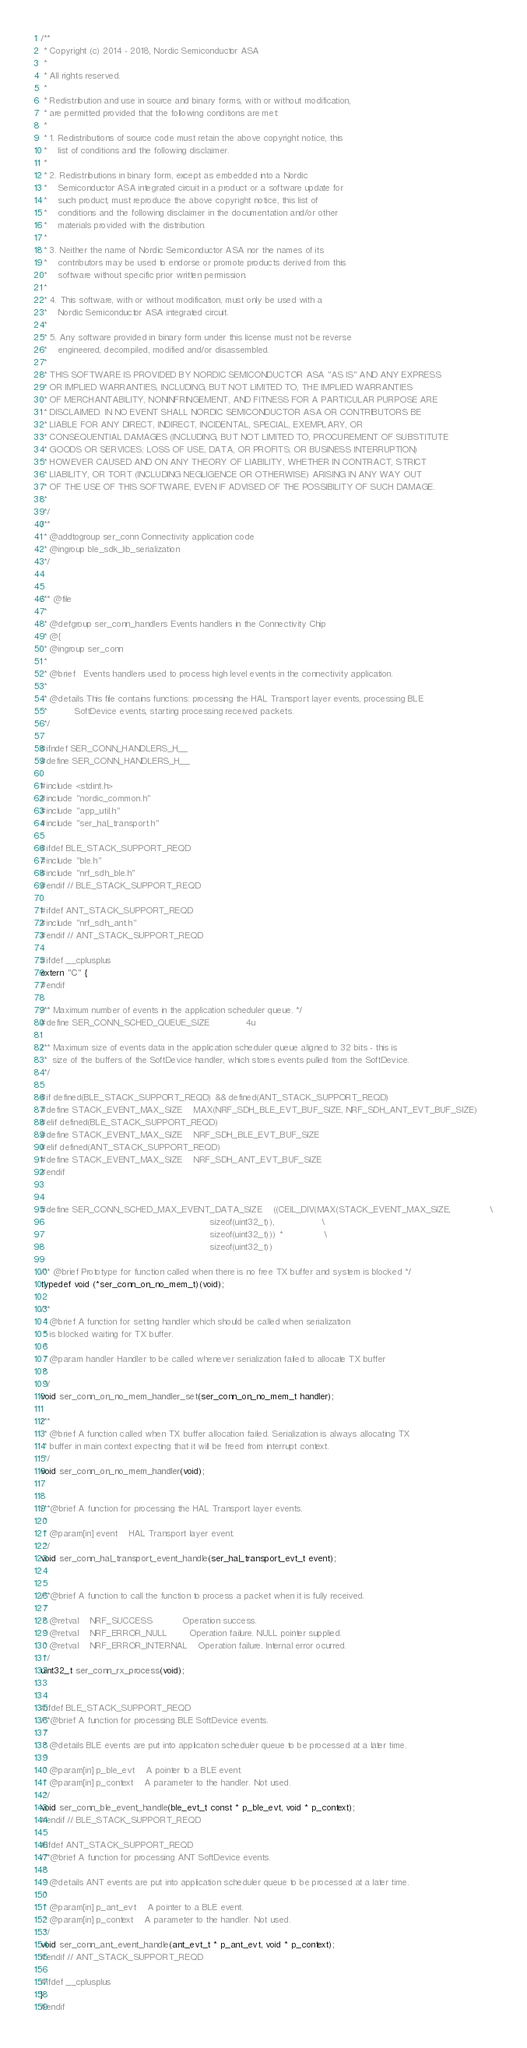<code> <loc_0><loc_0><loc_500><loc_500><_C_>/**
 * Copyright (c) 2014 - 2018, Nordic Semiconductor ASA
 * 
 * All rights reserved.
 * 
 * Redistribution and use in source and binary forms, with or without modification,
 * are permitted provided that the following conditions are met:
 * 
 * 1. Redistributions of source code must retain the above copyright notice, this
 *    list of conditions and the following disclaimer.
 * 
 * 2. Redistributions in binary form, except as embedded into a Nordic
 *    Semiconductor ASA integrated circuit in a product or a software update for
 *    such product, must reproduce the above copyright notice, this list of
 *    conditions and the following disclaimer in the documentation and/or other
 *    materials provided with the distribution.
 * 
 * 3. Neither the name of Nordic Semiconductor ASA nor the names of its
 *    contributors may be used to endorse or promote products derived from this
 *    software without specific prior written permission.
 * 
 * 4. This software, with or without modification, must only be used with a
 *    Nordic Semiconductor ASA integrated circuit.
 * 
 * 5. Any software provided in binary form under this license must not be reverse
 *    engineered, decompiled, modified and/or disassembled.
 * 
 * THIS SOFTWARE IS PROVIDED BY NORDIC SEMICONDUCTOR ASA "AS IS" AND ANY EXPRESS
 * OR IMPLIED WARRANTIES, INCLUDING, BUT NOT LIMITED TO, THE IMPLIED WARRANTIES
 * OF MERCHANTABILITY, NONINFRINGEMENT, AND FITNESS FOR A PARTICULAR PURPOSE ARE
 * DISCLAIMED. IN NO EVENT SHALL NORDIC SEMICONDUCTOR ASA OR CONTRIBUTORS BE
 * LIABLE FOR ANY DIRECT, INDIRECT, INCIDENTAL, SPECIAL, EXEMPLARY, OR
 * CONSEQUENTIAL DAMAGES (INCLUDING, BUT NOT LIMITED TO, PROCUREMENT OF SUBSTITUTE
 * GOODS OR SERVICES; LOSS OF USE, DATA, OR PROFITS; OR BUSINESS INTERRUPTION)
 * HOWEVER CAUSED AND ON ANY THEORY OF LIABILITY, WHETHER IN CONTRACT, STRICT
 * LIABILITY, OR TORT (INCLUDING NEGLIGENCE OR OTHERWISE) ARISING IN ANY WAY OUT
 * OF THE USE OF THIS SOFTWARE, EVEN IF ADVISED OF THE POSSIBILITY OF SUCH DAMAGE.
 * 
 */
/**
 * @addtogroup ser_conn Connectivity application code
 * @ingroup ble_sdk_lib_serialization
 */


/** @file
 *
 * @defgroup ser_conn_handlers Events handlers in the Connectivity Chip
 * @{
 * @ingroup ser_conn
 *
 * @brief   Events handlers used to process high level events in the connectivity application.
 *
 * @details This file contains functions: processing the HAL Transport layer events, processing BLE
 *          SoftDevice events, starting processing received packets.
 */

#ifndef SER_CONN_HANDLERS_H__
#define SER_CONN_HANDLERS_H__

#include <stdint.h>
#include "nordic_common.h"
#include "app_util.h"
#include "ser_hal_transport.h"

#ifdef BLE_STACK_SUPPORT_REQD
#include "ble.h"
#include "nrf_sdh_ble.h"
#endif // BLE_STACK_SUPPORT_REQD

#ifdef ANT_STACK_SUPPORT_REQD
#include "nrf_sdh_ant.h"
#endif // ANT_STACK_SUPPORT_REQD

#ifdef __cplusplus
extern "C" {
#endif

/** Maximum number of events in the application scheduler queue. */
#define SER_CONN_SCHED_QUEUE_SIZE             4u

/** Maximum size of events data in the application scheduler queue aligned to 32 bits - this is
 *  size of the buffers of the SoftDevice handler, which stores events pulled from the SoftDevice.
 */

#if defined(BLE_STACK_SUPPORT_REQD) && defined(ANT_STACK_SUPPORT_REQD)
#define STACK_EVENT_MAX_SIZE    MAX(NRF_SDH_BLE_EVT_BUF_SIZE, NRF_SDH_ANT_EVT_BUF_SIZE)
#elif defined(BLE_STACK_SUPPORT_REQD)
#define STACK_EVENT_MAX_SIZE    NRF_SDH_BLE_EVT_BUF_SIZE
#elif defined(ANT_STACK_SUPPORT_REQD)
#define STACK_EVENT_MAX_SIZE    NRF_SDH_ANT_EVT_BUF_SIZE
#endif


#define SER_CONN_SCHED_MAX_EVENT_DATA_SIZE    ((CEIL_DIV(MAX(STACK_EVENT_MAX_SIZE,              \
                                                             sizeof(uint32_t)),                 \
                                                             sizeof(uint32_t))) *               \
                                                             sizeof(uint32_t))

/** @brief Prototype for function called when there is no free TX buffer and system is blocked */
typedef void (*ser_conn_on_no_mem_t)(void);

/**
 * @brief A function for setting handler which should be called when serialization
 * is blocked waiting for TX buffer.
 *
 * @param handler Handler to be called whenever serialization failed to allocate TX buffer
 *
 */
void ser_conn_on_no_mem_handler_set(ser_conn_on_no_mem_t handler);

/**
 * @brief A function called when TX buffer allocation failed. Serialization is always allocating TX
 * buffer in main context expecting that it will be freed from interrupt context.
 */
void ser_conn_on_no_mem_handler(void);


/**@brief A function for processing the HAL Transport layer events.
 *
 * @param[in] event    HAL Transport layer event.
 */
void ser_conn_hal_transport_event_handle(ser_hal_transport_evt_t event);


/**@brief A function to call the function to process a packet when it is fully received.
 *
 * @retval    NRF_SUCCESS           Operation success.
 * @retval    NRF_ERROR_NULL        Operation failure. NULL pointer supplied.
 * @retval    NRF_ERROR_INTERNAL    Operation failure. Internal error ocurred.
 */
uint32_t ser_conn_rx_process(void);


#ifdef BLE_STACK_SUPPORT_REQD
/**@brief A function for processing BLE SoftDevice events.
 *
 * @details BLE events are put into application scheduler queue to be processed at a later time.
 *
 * @param[in] p_ble_evt    A pointer to a BLE event.
 * @param[in] p_context    A parameter to the handler. Not used.
 */
void ser_conn_ble_event_handle(ble_evt_t const * p_ble_evt, void * p_context);
#endif // BLE_STACK_SUPPORT_REQD

#ifdef ANT_STACK_SUPPORT_REQD
/**@brief A function for processing ANT SoftDevice events.
 *
 * @details ANT events are put into application scheduler queue to be processed at a later time.
 *
 * @param[in] p_ant_evt    A pointer to a BLE event.
 * @param[in] p_context    A parameter to the handler. Not used.
 */
void ser_conn_ant_event_handle(ant_evt_t * p_ant_evt, void * p_context);
#endif // ANT_STACK_SUPPORT_REQD

#ifdef __cplusplus
}
#endif
</code> 